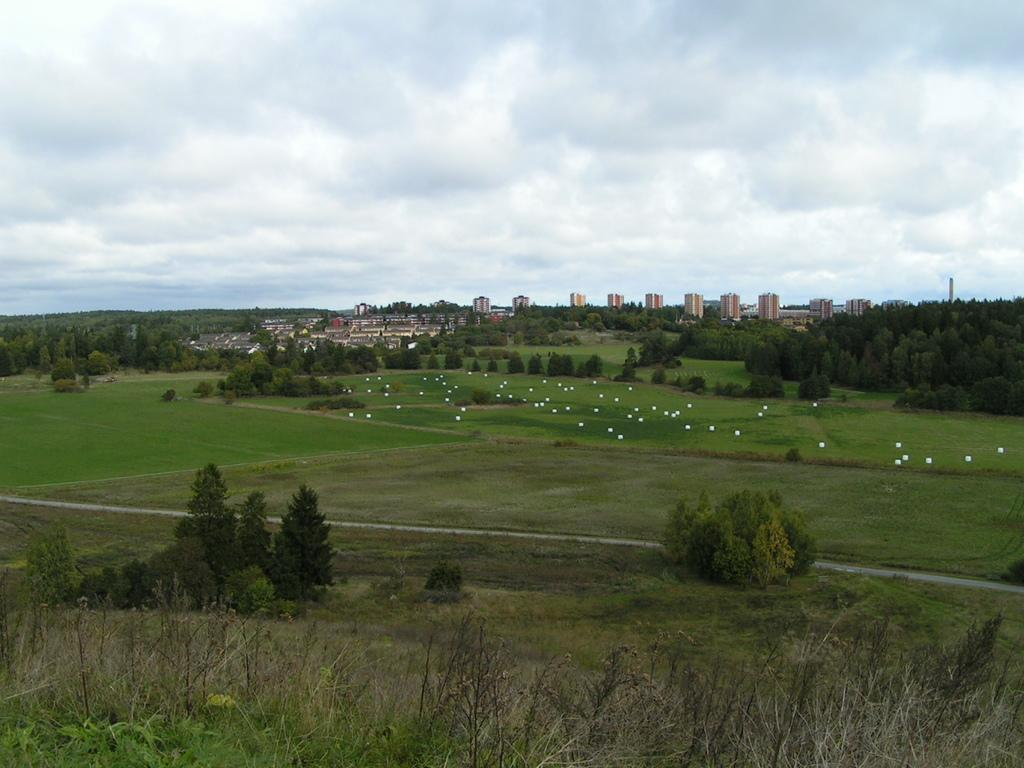What type of vegetation can be seen in the image? There are plants, trees, and grass visible in the image. What structures can be seen in the background of the image? There are buildings and houses in the background of the image. What is visible at the top of the image? The sky is visible at the top of the image. What is the condition of the sky in the image? The sky appears to be cloudy in the image. What color objects can be seen in the image? There are white color objects in the image. How much respect can be seen in the image? Respect is not a tangible object that can be seen in the image. Is there any money visible in the image? There is no mention of money in the provided facts, and therefore it cannot be determined if money is visible in the image. 